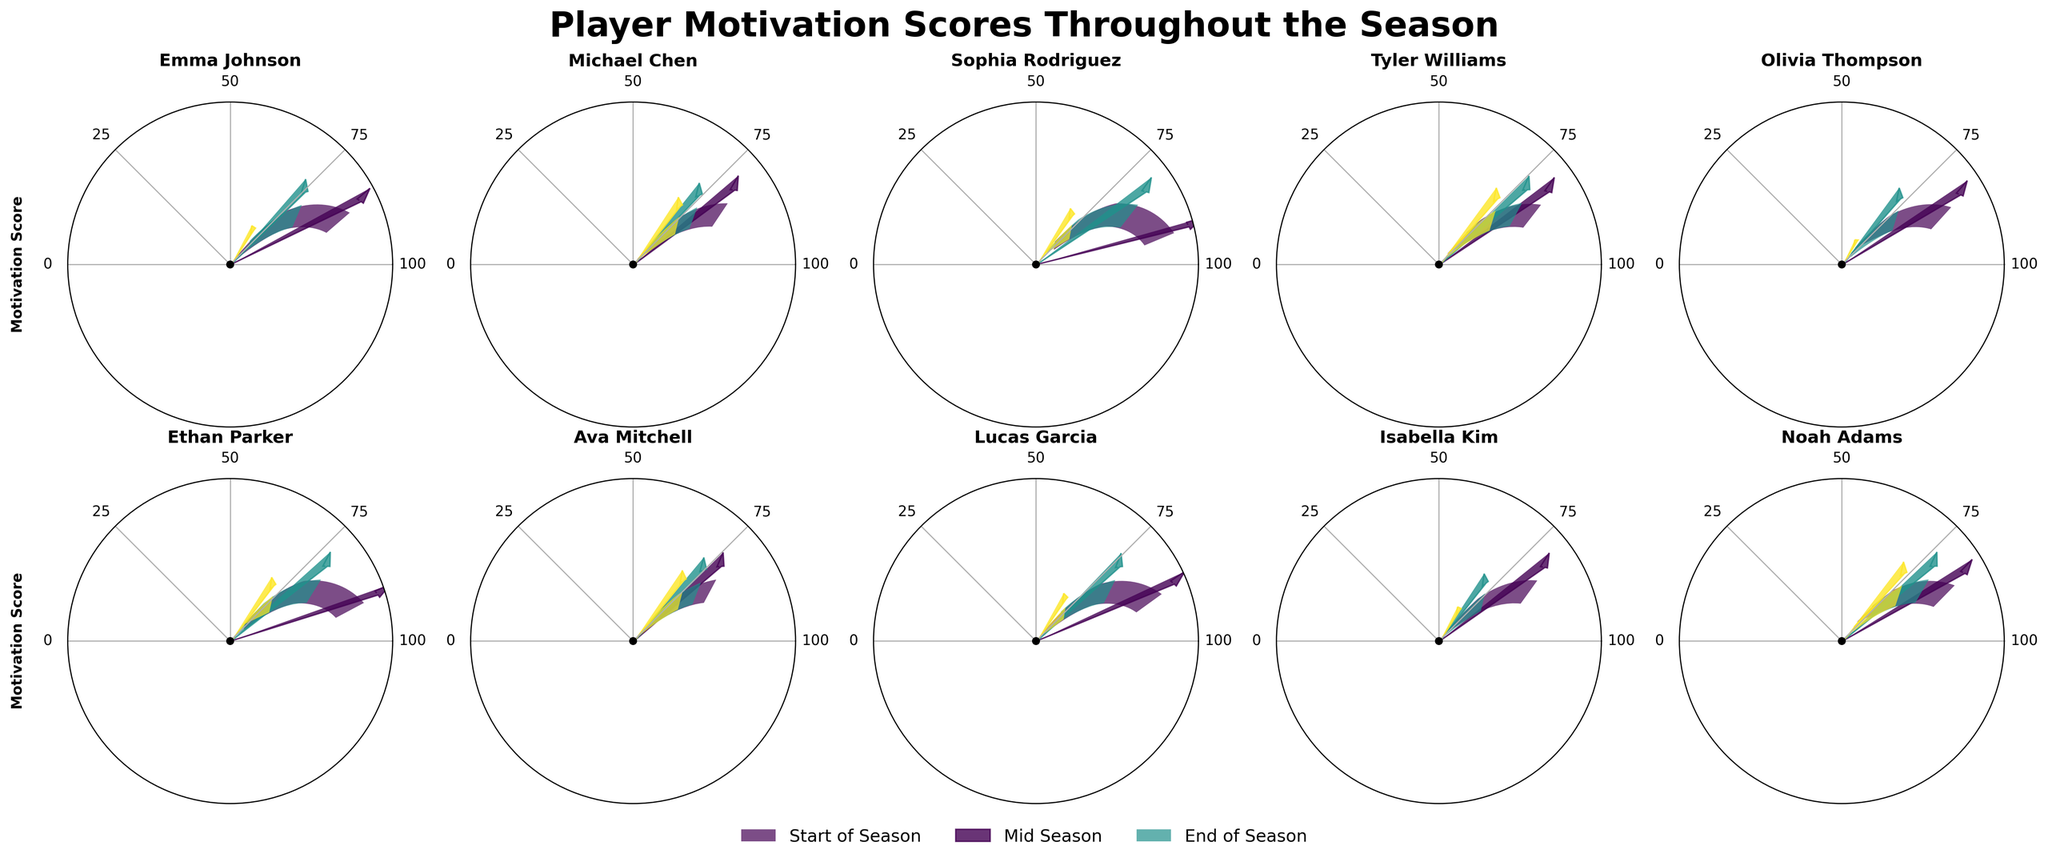What's the title of the figure? The title of a figure is usually located at the top center. By looking at the top center of the figure, we can see the title "Player Motivation Scores Throughout the Season."
Answer: Player Motivation Scores Throughout the Season Which player had the highest motivation score at the end of the season? To find the highest motivation score at the end of the season, we look at the last gauge on each player's panel and compare the values. Olivia Thompson has the highest score of 95.
Answer: Olivia Thompson How did Emma Johnson's motivation score change from the start to the end of the season? By comparing the gauge angles for Emma Johnson, we see that her score increases from 65 at the start to 92 at the end.
Answer: Increased from 65 to 92 Which player showed the least improvement from mid-season to end of the season? To determine the player with the least improvement, we subtract the mid-season score from the end-of-season score for each player. Noah Adams improved the least, with only a 7-point increase (74 to 81).
Answer: Noah Adams What is the average motivation score at the end of the season across all players? To find the average end-of-season score, add the end-of-season scores for all players and divide by the number of players: (92+85+88+82+95+86+84+90+93+81)/10 = 87.6.
Answer: 87.6 Who had the most consistent motivation score throughout the season? To find the most consistent player, we need to identify the player with the smallest range between their start, mid, and end-of-season scores. Ava Mitchell had scores of 75, 79, and 84, with a range of 9 (84-75).
Answer: Ava Mitchell Which phase of the season saw the highest overall improvement in motivation scores? To find the phase with the highest improvement, we calculate the total improvements for each phase. Add the differences of scores from start to mid-season and mid to end-season, then compare. The largest increase is from the start to the end of the season.
Answer: Start to End of Season Who had the highest motivation score at the mid-point of the season? To find the highest mid-season motivation score, we compare the mid-season scores of all players. Isabella Kim has the highest mid-season score of 85.
Answer: Isabella Kim What is the total increase in motivation score for Sophia Rodriguez over the season? To find Sophia Rodriguez's total increase, we subtract her start-of-season score from her end-of-season score: 88 - 58 = 30.
Answer: 30 